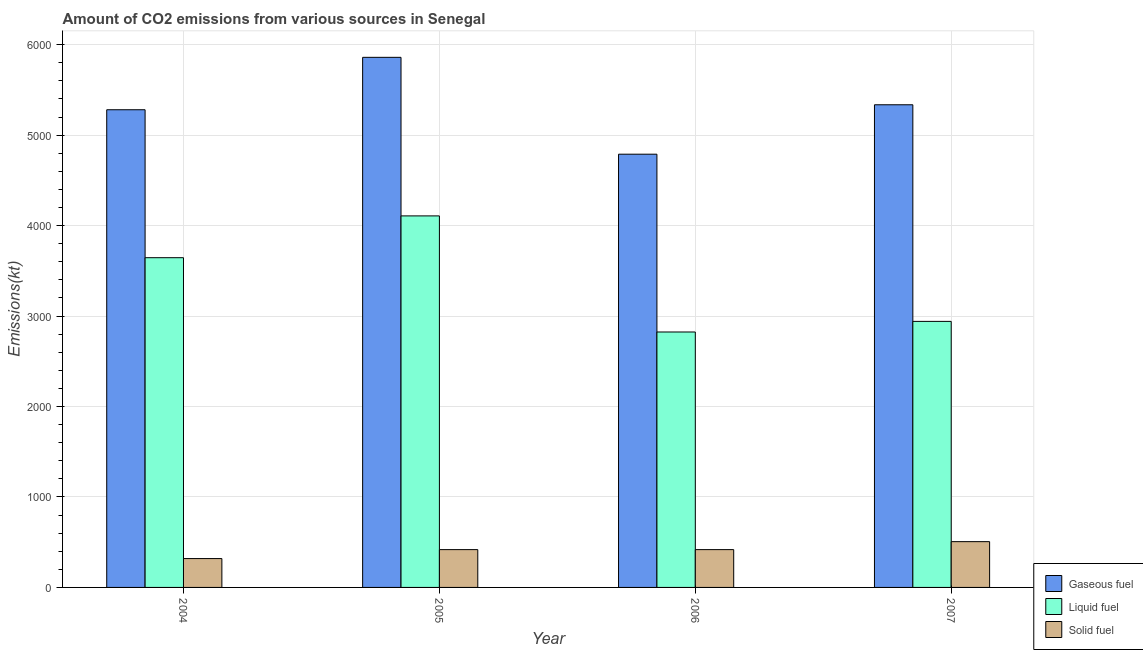How many different coloured bars are there?
Ensure brevity in your answer.  3. How many groups of bars are there?
Ensure brevity in your answer.  4. Are the number of bars per tick equal to the number of legend labels?
Give a very brief answer. Yes. Are the number of bars on each tick of the X-axis equal?
Your response must be concise. Yes. How many bars are there on the 4th tick from the left?
Ensure brevity in your answer.  3. What is the amount of co2 emissions from liquid fuel in 2006?
Offer a terse response. 2823.59. Across all years, what is the maximum amount of co2 emissions from gaseous fuel?
Offer a very short reply. 5859.87. Across all years, what is the minimum amount of co2 emissions from gaseous fuel?
Your answer should be very brief. 4789.1. In which year was the amount of co2 emissions from liquid fuel minimum?
Offer a very short reply. 2006. What is the total amount of co2 emissions from liquid fuel in the graph?
Provide a short and direct response. 1.35e+04. What is the difference between the amount of co2 emissions from gaseous fuel in 2006 and that in 2007?
Your answer should be compact. -546.38. What is the difference between the amount of co2 emissions from solid fuel in 2007 and the amount of co2 emissions from liquid fuel in 2005?
Your response must be concise. 88.01. What is the average amount of co2 emissions from solid fuel per year?
Offer a terse response. 415.29. In how many years, is the amount of co2 emissions from liquid fuel greater than 2600 kt?
Ensure brevity in your answer.  4. What is the ratio of the amount of co2 emissions from gaseous fuel in 2006 to that in 2007?
Keep it short and to the point. 0.9. What is the difference between the highest and the second highest amount of co2 emissions from gaseous fuel?
Offer a very short reply. 524.38. What is the difference between the highest and the lowest amount of co2 emissions from gaseous fuel?
Offer a terse response. 1070.76. In how many years, is the amount of co2 emissions from liquid fuel greater than the average amount of co2 emissions from liquid fuel taken over all years?
Provide a short and direct response. 2. Is the sum of the amount of co2 emissions from solid fuel in 2004 and 2005 greater than the maximum amount of co2 emissions from liquid fuel across all years?
Your answer should be very brief. Yes. What does the 1st bar from the left in 2007 represents?
Provide a short and direct response. Gaseous fuel. What does the 1st bar from the right in 2005 represents?
Your answer should be compact. Solid fuel. Is it the case that in every year, the sum of the amount of co2 emissions from gaseous fuel and amount of co2 emissions from liquid fuel is greater than the amount of co2 emissions from solid fuel?
Provide a short and direct response. Yes. How many bars are there?
Your response must be concise. 12. Are all the bars in the graph horizontal?
Provide a succinct answer. No. Does the graph contain grids?
Provide a succinct answer. Yes. How are the legend labels stacked?
Provide a succinct answer. Vertical. What is the title of the graph?
Make the answer very short. Amount of CO2 emissions from various sources in Senegal. Does "Natural Gas" appear as one of the legend labels in the graph?
Your answer should be very brief. No. What is the label or title of the Y-axis?
Ensure brevity in your answer.  Emissions(kt). What is the Emissions(kt) in Gaseous fuel in 2004?
Ensure brevity in your answer.  5280.48. What is the Emissions(kt) in Liquid fuel in 2004?
Your answer should be compact. 3645. What is the Emissions(kt) of Solid fuel in 2004?
Provide a succinct answer. 319.03. What is the Emissions(kt) of Gaseous fuel in 2005?
Your response must be concise. 5859.87. What is the Emissions(kt) in Liquid fuel in 2005?
Ensure brevity in your answer.  4107.04. What is the Emissions(kt) of Solid fuel in 2005?
Offer a very short reply. 418.04. What is the Emissions(kt) in Gaseous fuel in 2006?
Your response must be concise. 4789.1. What is the Emissions(kt) in Liquid fuel in 2006?
Your answer should be compact. 2823.59. What is the Emissions(kt) in Solid fuel in 2006?
Your answer should be very brief. 418.04. What is the Emissions(kt) in Gaseous fuel in 2007?
Offer a terse response. 5335.48. What is the Emissions(kt) of Liquid fuel in 2007?
Your response must be concise. 2940.93. What is the Emissions(kt) of Solid fuel in 2007?
Offer a terse response. 506.05. Across all years, what is the maximum Emissions(kt) in Gaseous fuel?
Offer a terse response. 5859.87. Across all years, what is the maximum Emissions(kt) in Liquid fuel?
Make the answer very short. 4107.04. Across all years, what is the maximum Emissions(kt) of Solid fuel?
Give a very brief answer. 506.05. Across all years, what is the minimum Emissions(kt) in Gaseous fuel?
Provide a short and direct response. 4789.1. Across all years, what is the minimum Emissions(kt) in Liquid fuel?
Keep it short and to the point. 2823.59. Across all years, what is the minimum Emissions(kt) in Solid fuel?
Ensure brevity in your answer.  319.03. What is the total Emissions(kt) of Gaseous fuel in the graph?
Your answer should be very brief. 2.13e+04. What is the total Emissions(kt) in Liquid fuel in the graph?
Your answer should be compact. 1.35e+04. What is the total Emissions(kt) of Solid fuel in the graph?
Offer a terse response. 1661.15. What is the difference between the Emissions(kt) in Gaseous fuel in 2004 and that in 2005?
Offer a terse response. -579.39. What is the difference between the Emissions(kt) in Liquid fuel in 2004 and that in 2005?
Make the answer very short. -462.04. What is the difference between the Emissions(kt) of Solid fuel in 2004 and that in 2005?
Offer a terse response. -99.01. What is the difference between the Emissions(kt) of Gaseous fuel in 2004 and that in 2006?
Ensure brevity in your answer.  491.38. What is the difference between the Emissions(kt) of Liquid fuel in 2004 and that in 2006?
Your response must be concise. 821.41. What is the difference between the Emissions(kt) of Solid fuel in 2004 and that in 2006?
Ensure brevity in your answer.  -99.01. What is the difference between the Emissions(kt) of Gaseous fuel in 2004 and that in 2007?
Your answer should be very brief. -55.01. What is the difference between the Emissions(kt) of Liquid fuel in 2004 and that in 2007?
Offer a terse response. 704.06. What is the difference between the Emissions(kt) in Solid fuel in 2004 and that in 2007?
Keep it short and to the point. -187.02. What is the difference between the Emissions(kt) in Gaseous fuel in 2005 and that in 2006?
Provide a succinct answer. 1070.76. What is the difference between the Emissions(kt) of Liquid fuel in 2005 and that in 2006?
Offer a terse response. 1283.45. What is the difference between the Emissions(kt) in Gaseous fuel in 2005 and that in 2007?
Offer a terse response. 524.38. What is the difference between the Emissions(kt) of Liquid fuel in 2005 and that in 2007?
Your response must be concise. 1166.11. What is the difference between the Emissions(kt) in Solid fuel in 2005 and that in 2007?
Give a very brief answer. -88.01. What is the difference between the Emissions(kt) in Gaseous fuel in 2006 and that in 2007?
Your answer should be compact. -546.38. What is the difference between the Emissions(kt) in Liquid fuel in 2006 and that in 2007?
Provide a succinct answer. -117.34. What is the difference between the Emissions(kt) in Solid fuel in 2006 and that in 2007?
Offer a very short reply. -88.01. What is the difference between the Emissions(kt) of Gaseous fuel in 2004 and the Emissions(kt) of Liquid fuel in 2005?
Keep it short and to the point. 1173.44. What is the difference between the Emissions(kt) in Gaseous fuel in 2004 and the Emissions(kt) in Solid fuel in 2005?
Offer a very short reply. 4862.44. What is the difference between the Emissions(kt) of Liquid fuel in 2004 and the Emissions(kt) of Solid fuel in 2005?
Provide a short and direct response. 3226.96. What is the difference between the Emissions(kt) in Gaseous fuel in 2004 and the Emissions(kt) in Liquid fuel in 2006?
Keep it short and to the point. 2456.89. What is the difference between the Emissions(kt) in Gaseous fuel in 2004 and the Emissions(kt) in Solid fuel in 2006?
Give a very brief answer. 4862.44. What is the difference between the Emissions(kt) in Liquid fuel in 2004 and the Emissions(kt) in Solid fuel in 2006?
Provide a succinct answer. 3226.96. What is the difference between the Emissions(kt) in Gaseous fuel in 2004 and the Emissions(kt) in Liquid fuel in 2007?
Your response must be concise. 2339.55. What is the difference between the Emissions(kt) of Gaseous fuel in 2004 and the Emissions(kt) of Solid fuel in 2007?
Your response must be concise. 4774.43. What is the difference between the Emissions(kt) of Liquid fuel in 2004 and the Emissions(kt) of Solid fuel in 2007?
Provide a short and direct response. 3138.95. What is the difference between the Emissions(kt) in Gaseous fuel in 2005 and the Emissions(kt) in Liquid fuel in 2006?
Your answer should be very brief. 3036.28. What is the difference between the Emissions(kt) of Gaseous fuel in 2005 and the Emissions(kt) of Solid fuel in 2006?
Make the answer very short. 5441.83. What is the difference between the Emissions(kt) in Liquid fuel in 2005 and the Emissions(kt) in Solid fuel in 2006?
Give a very brief answer. 3689. What is the difference between the Emissions(kt) of Gaseous fuel in 2005 and the Emissions(kt) of Liquid fuel in 2007?
Your answer should be compact. 2918.93. What is the difference between the Emissions(kt) of Gaseous fuel in 2005 and the Emissions(kt) of Solid fuel in 2007?
Ensure brevity in your answer.  5353.82. What is the difference between the Emissions(kt) in Liquid fuel in 2005 and the Emissions(kt) in Solid fuel in 2007?
Provide a succinct answer. 3600.99. What is the difference between the Emissions(kt) in Gaseous fuel in 2006 and the Emissions(kt) in Liquid fuel in 2007?
Your answer should be compact. 1848.17. What is the difference between the Emissions(kt) of Gaseous fuel in 2006 and the Emissions(kt) of Solid fuel in 2007?
Provide a succinct answer. 4283.06. What is the difference between the Emissions(kt) of Liquid fuel in 2006 and the Emissions(kt) of Solid fuel in 2007?
Give a very brief answer. 2317.54. What is the average Emissions(kt) of Gaseous fuel per year?
Offer a very short reply. 5316.23. What is the average Emissions(kt) of Liquid fuel per year?
Offer a terse response. 3379.14. What is the average Emissions(kt) in Solid fuel per year?
Your answer should be compact. 415.29. In the year 2004, what is the difference between the Emissions(kt) of Gaseous fuel and Emissions(kt) of Liquid fuel?
Your answer should be compact. 1635.48. In the year 2004, what is the difference between the Emissions(kt) in Gaseous fuel and Emissions(kt) in Solid fuel?
Your response must be concise. 4961.45. In the year 2004, what is the difference between the Emissions(kt) of Liquid fuel and Emissions(kt) of Solid fuel?
Make the answer very short. 3325.97. In the year 2005, what is the difference between the Emissions(kt) in Gaseous fuel and Emissions(kt) in Liquid fuel?
Ensure brevity in your answer.  1752.83. In the year 2005, what is the difference between the Emissions(kt) of Gaseous fuel and Emissions(kt) of Solid fuel?
Make the answer very short. 5441.83. In the year 2005, what is the difference between the Emissions(kt) in Liquid fuel and Emissions(kt) in Solid fuel?
Provide a succinct answer. 3689. In the year 2006, what is the difference between the Emissions(kt) of Gaseous fuel and Emissions(kt) of Liquid fuel?
Keep it short and to the point. 1965.51. In the year 2006, what is the difference between the Emissions(kt) in Gaseous fuel and Emissions(kt) in Solid fuel?
Offer a terse response. 4371.06. In the year 2006, what is the difference between the Emissions(kt) in Liquid fuel and Emissions(kt) in Solid fuel?
Give a very brief answer. 2405.55. In the year 2007, what is the difference between the Emissions(kt) of Gaseous fuel and Emissions(kt) of Liquid fuel?
Provide a succinct answer. 2394.55. In the year 2007, what is the difference between the Emissions(kt) in Gaseous fuel and Emissions(kt) in Solid fuel?
Provide a short and direct response. 4829.44. In the year 2007, what is the difference between the Emissions(kt) of Liquid fuel and Emissions(kt) of Solid fuel?
Give a very brief answer. 2434.89. What is the ratio of the Emissions(kt) of Gaseous fuel in 2004 to that in 2005?
Offer a very short reply. 0.9. What is the ratio of the Emissions(kt) of Liquid fuel in 2004 to that in 2005?
Your answer should be compact. 0.89. What is the ratio of the Emissions(kt) in Solid fuel in 2004 to that in 2005?
Keep it short and to the point. 0.76. What is the ratio of the Emissions(kt) of Gaseous fuel in 2004 to that in 2006?
Make the answer very short. 1.1. What is the ratio of the Emissions(kt) of Liquid fuel in 2004 to that in 2006?
Provide a short and direct response. 1.29. What is the ratio of the Emissions(kt) of Solid fuel in 2004 to that in 2006?
Ensure brevity in your answer.  0.76. What is the ratio of the Emissions(kt) of Liquid fuel in 2004 to that in 2007?
Offer a terse response. 1.24. What is the ratio of the Emissions(kt) of Solid fuel in 2004 to that in 2007?
Offer a very short reply. 0.63. What is the ratio of the Emissions(kt) in Gaseous fuel in 2005 to that in 2006?
Provide a short and direct response. 1.22. What is the ratio of the Emissions(kt) of Liquid fuel in 2005 to that in 2006?
Provide a succinct answer. 1.45. What is the ratio of the Emissions(kt) of Gaseous fuel in 2005 to that in 2007?
Make the answer very short. 1.1. What is the ratio of the Emissions(kt) of Liquid fuel in 2005 to that in 2007?
Offer a very short reply. 1.4. What is the ratio of the Emissions(kt) of Solid fuel in 2005 to that in 2007?
Your answer should be very brief. 0.83. What is the ratio of the Emissions(kt) in Gaseous fuel in 2006 to that in 2007?
Provide a succinct answer. 0.9. What is the ratio of the Emissions(kt) in Liquid fuel in 2006 to that in 2007?
Your answer should be very brief. 0.96. What is the ratio of the Emissions(kt) in Solid fuel in 2006 to that in 2007?
Keep it short and to the point. 0.83. What is the difference between the highest and the second highest Emissions(kt) of Gaseous fuel?
Offer a terse response. 524.38. What is the difference between the highest and the second highest Emissions(kt) of Liquid fuel?
Your answer should be very brief. 462.04. What is the difference between the highest and the second highest Emissions(kt) of Solid fuel?
Give a very brief answer. 88.01. What is the difference between the highest and the lowest Emissions(kt) of Gaseous fuel?
Provide a short and direct response. 1070.76. What is the difference between the highest and the lowest Emissions(kt) in Liquid fuel?
Ensure brevity in your answer.  1283.45. What is the difference between the highest and the lowest Emissions(kt) in Solid fuel?
Your response must be concise. 187.02. 